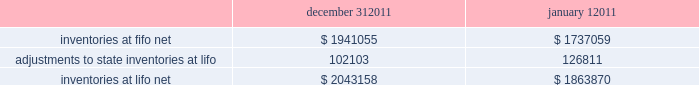Advance auto parts , inc .
And subsidiaries notes to the consolidated financial statements december 31 , 2011 , january 1 , 2011 and january 2 , 2010 ( in thousands , except per share data ) 2011-12 superseded certain pending paragraphs in asu 2011-05 201ccomprehensive income 2013 presentation of comprehensive income 201d to effectively defer only those changes in asu 2011-05 that related to the presentation of reclassification adjustments out of accumulated other comprehensive income .
The adoption of asu 2011-05 is not expected to have a material impact on the company 2019s consolidated financial condition , results of operations or cash flows .
In january 2010 , the fasb issued asu no .
2010-06 201cfair value measurements and disclosures 2013 improving disclosures about fair value measurements . 201d asu 2010-06 requires new disclosures for significant transfers in and out of level 1 and 2 of the fair value hierarchy and the activity within level 3 of the fair value hierarchy .
The updated guidance also clarifies existing disclosures regarding the level of disaggregation of assets or liabilities and the valuation techniques and inputs used to measure fair value .
The updated guidance is effective for interim and annual reporting periods beginning after december 15 , 2009 , with the exception of the new level 3 activity disclosures , which are effective for interim and annual reporting periods beginning after december 15 , 2010 .
The adoption of asu 2010-06 had no impact on the company 2019s consolidated financial condition , results of operations or cash flows .
Inventories , net : merchandise inventory the company used the lifo method of accounting for approximately 95% ( 95 % ) of inventories at december 31 , 2011 and january 1 , 2011 .
Under lifo , the company 2019s cost of sales reflects the costs of the most recently purchased inventories , while the inventory carrying balance represents the costs for inventories purchased in fiscal 2011 and prior years .
As a result of utilizing lifo , the company recorded an increase to cost of sales of $ 24708 for fiscal 2011 due to an increase in supply chain costs and inflationary pressures affecting certain product categories .
The company recorded a reduction to cost of sales of $ 29554 and $ 16040 for fiscal 2010 and 2009 , respectively .
Prior to fiscal 2011 , the company 2019s overall costs to acquire inventory for the same or similar products generally decreased historically as the company has been able to leverage its continued growth , execution of merchandise strategies and realization of supply chain efficiencies .
Product cores the remaining inventories are comprised of product cores , the non-consumable portion of certain parts and batteries , which are valued under the first-in , first-out ( "fifo" ) method .
Product cores are included as part of the company's merchandise costs and are either passed on to the customer or returned to the vendor .
Because product cores are not subject to frequent cost changes like the company's other merchandise inventory , there is no material difference when applying either the lifo or fifo valuation method .
Inventory overhead costs purchasing and warehousing costs included in inventory , at fifo , at december 31 , 2011 and january 1 , 2011 , were $ 126840 and $ 103989 , respectively .
Inventory balance and inventory reserves inventory balances at year-end for fiscal 2011 and 2010 were as follows : inventories at fifo , net adjustments to state inventories at lifo inventories at lifo , net december 31 , $ 1941055 102103 $ 2043158 january 1 , $ 1737059 126811 $ 1863870 .
Advance auto parts , inc .
And subsidiaries notes to the consolidated financial statements december 31 , 2011 , january 1 , 2011 and january 2 , 2010 ( in thousands , except per share data ) 2011-12 superseded certain pending paragraphs in asu 2011-05 201ccomprehensive income 2013 presentation of comprehensive income 201d to effectively defer only those changes in asu 2011-05 that related to the presentation of reclassification adjustments out of accumulated other comprehensive income .
The adoption of asu 2011-05 is not expected to have a material impact on the company 2019s consolidated financial condition , results of operations or cash flows .
In january 2010 , the fasb issued asu no .
2010-06 201cfair value measurements and disclosures 2013 improving disclosures about fair value measurements . 201d asu 2010-06 requires new disclosures for significant transfers in and out of level 1 and 2 of the fair value hierarchy and the activity within level 3 of the fair value hierarchy .
The updated guidance also clarifies existing disclosures regarding the level of disaggregation of assets or liabilities and the valuation techniques and inputs used to measure fair value .
The updated guidance is effective for interim and annual reporting periods beginning after december 15 , 2009 , with the exception of the new level 3 activity disclosures , which are effective for interim and annual reporting periods beginning after december 15 , 2010 .
The adoption of asu 2010-06 had no impact on the company 2019s consolidated financial condition , results of operations or cash flows .
Inventories , net : merchandise inventory the company used the lifo method of accounting for approximately 95% ( 95 % ) of inventories at december 31 , 2011 and january 1 , 2011 .
Under lifo , the company 2019s cost of sales reflects the costs of the most recently purchased inventories , while the inventory carrying balance represents the costs for inventories purchased in fiscal 2011 and prior years .
As a result of utilizing lifo , the company recorded an increase to cost of sales of $ 24708 for fiscal 2011 due to an increase in supply chain costs and inflationary pressures affecting certain product categories .
The company recorded a reduction to cost of sales of $ 29554 and $ 16040 for fiscal 2010 and 2009 , respectively .
Prior to fiscal 2011 , the company 2019s overall costs to acquire inventory for the same or similar products generally decreased historically as the company has been able to leverage its continued growth , execution of merchandise strategies and realization of supply chain efficiencies .
Product cores the remaining inventories are comprised of product cores , the non-consumable portion of certain parts and batteries , which are valued under the first-in , first-out ( "fifo" ) method .
Product cores are included as part of the company's merchandise costs and are either passed on to the customer or returned to the vendor .
Because product cores are not subject to frequent cost changes like the company's other merchandise inventory , there is no material difference when applying either the lifo or fifo valuation method .
Inventory overhead costs purchasing and warehousing costs included in inventory , at fifo , at december 31 , 2011 and january 1 , 2011 , were $ 126840 and $ 103989 , respectively .
Inventory balance and inventory reserves inventory balances at year-end for fiscal 2011 and 2010 were as follows : inventories at fifo , net adjustments to state inventories at lifo inventories at lifo , net december 31 , $ 1941055 102103 $ 2043158 january 1 , $ 1737059 126811 $ 1863870 .
What percentage did ne inventories at lifo increase over the year? 
Rationale: to find the percentage increase in net inventories for lifo , one must subtract the end of the year by the begining of the year , then dvidie the answer by the beginning of the year .
Computations: ((2043158 - 1863870) / 1863870)
Answer: 0.09619. 